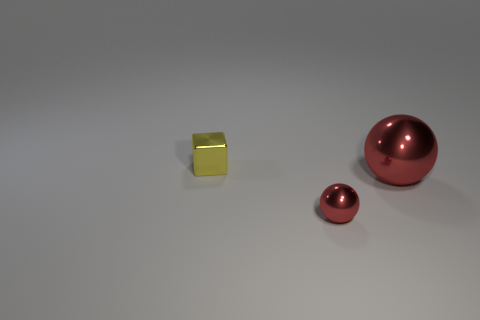Add 3 large red metallic balls. How many objects exist? 6 Subtract all blocks. How many objects are left? 2 Subtract 2 balls. How many balls are left? 0 Subtract 0 brown cylinders. How many objects are left? 3 Subtract all purple cubes. Subtract all brown cylinders. How many cubes are left? 1 Subtract all gray cylinders. How many cyan spheres are left? 0 Subtract all small red metallic balls. Subtract all shiny spheres. How many objects are left? 0 Add 2 small red shiny objects. How many small red shiny objects are left? 3 Add 2 large brown things. How many large brown things exist? 2 